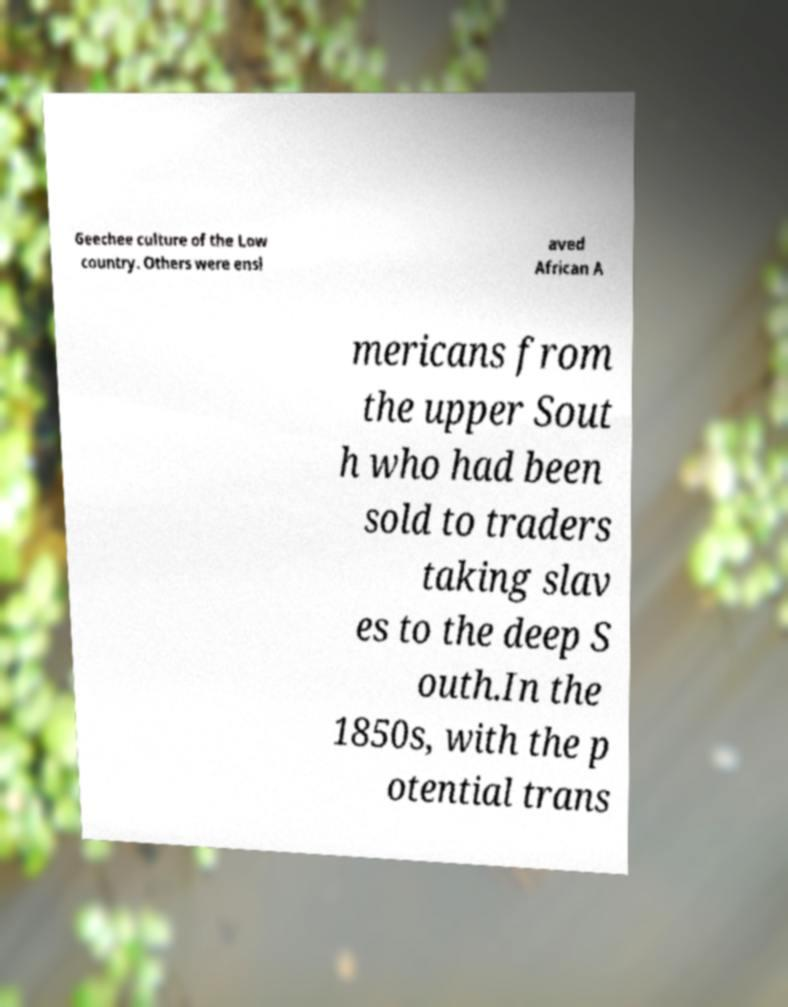What messages or text are displayed in this image? I need them in a readable, typed format. Geechee culture of the Low country. Others were ensl aved African A mericans from the upper Sout h who had been sold to traders taking slav es to the deep S outh.In the 1850s, with the p otential trans 